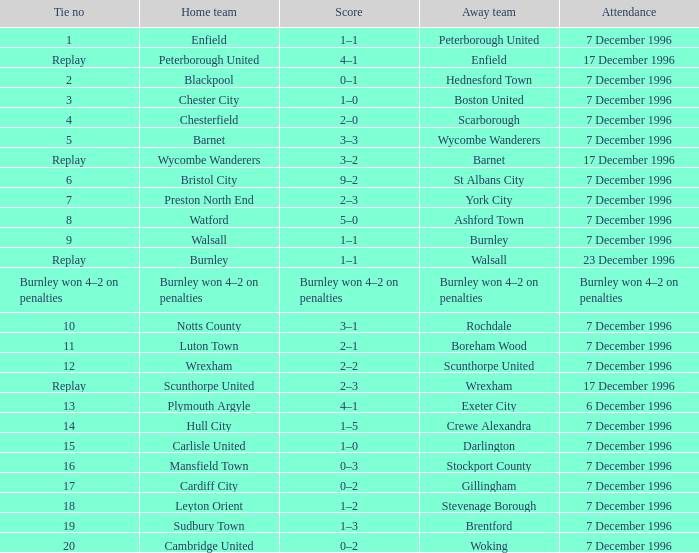Who were the guest team in fixture number 20? Woking. 